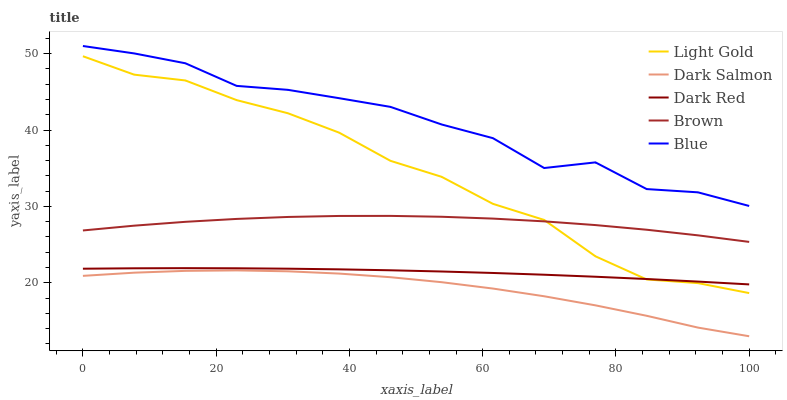Does Dark Salmon have the minimum area under the curve?
Answer yes or no. Yes. Does Blue have the maximum area under the curve?
Answer yes or no. Yes. Does Dark Red have the minimum area under the curve?
Answer yes or no. No. Does Dark Red have the maximum area under the curve?
Answer yes or no. No. Is Dark Red the smoothest?
Answer yes or no. Yes. Is Blue the roughest?
Answer yes or no. Yes. Is Light Gold the smoothest?
Answer yes or no. No. Is Light Gold the roughest?
Answer yes or no. No. Does Dark Salmon have the lowest value?
Answer yes or no. Yes. Does Dark Red have the lowest value?
Answer yes or no. No. Does Blue have the highest value?
Answer yes or no. Yes. Does Dark Red have the highest value?
Answer yes or no. No. Is Dark Salmon less than Blue?
Answer yes or no. Yes. Is Light Gold greater than Dark Salmon?
Answer yes or no. Yes. Does Light Gold intersect Dark Red?
Answer yes or no. Yes. Is Light Gold less than Dark Red?
Answer yes or no. No. Is Light Gold greater than Dark Red?
Answer yes or no. No. Does Dark Salmon intersect Blue?
Answer yes or no. No. 